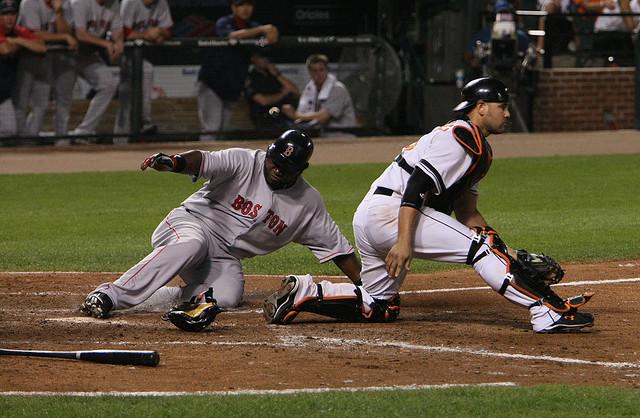Is there a bat on the ground?
Write a very short answer. Yes. Are both players on the ground?
Give a very brief answer. Yes. What is on the man's left knee?
Be succinct. Knee pad. Which sport are they playing?
Keep it brief. Baseball. 